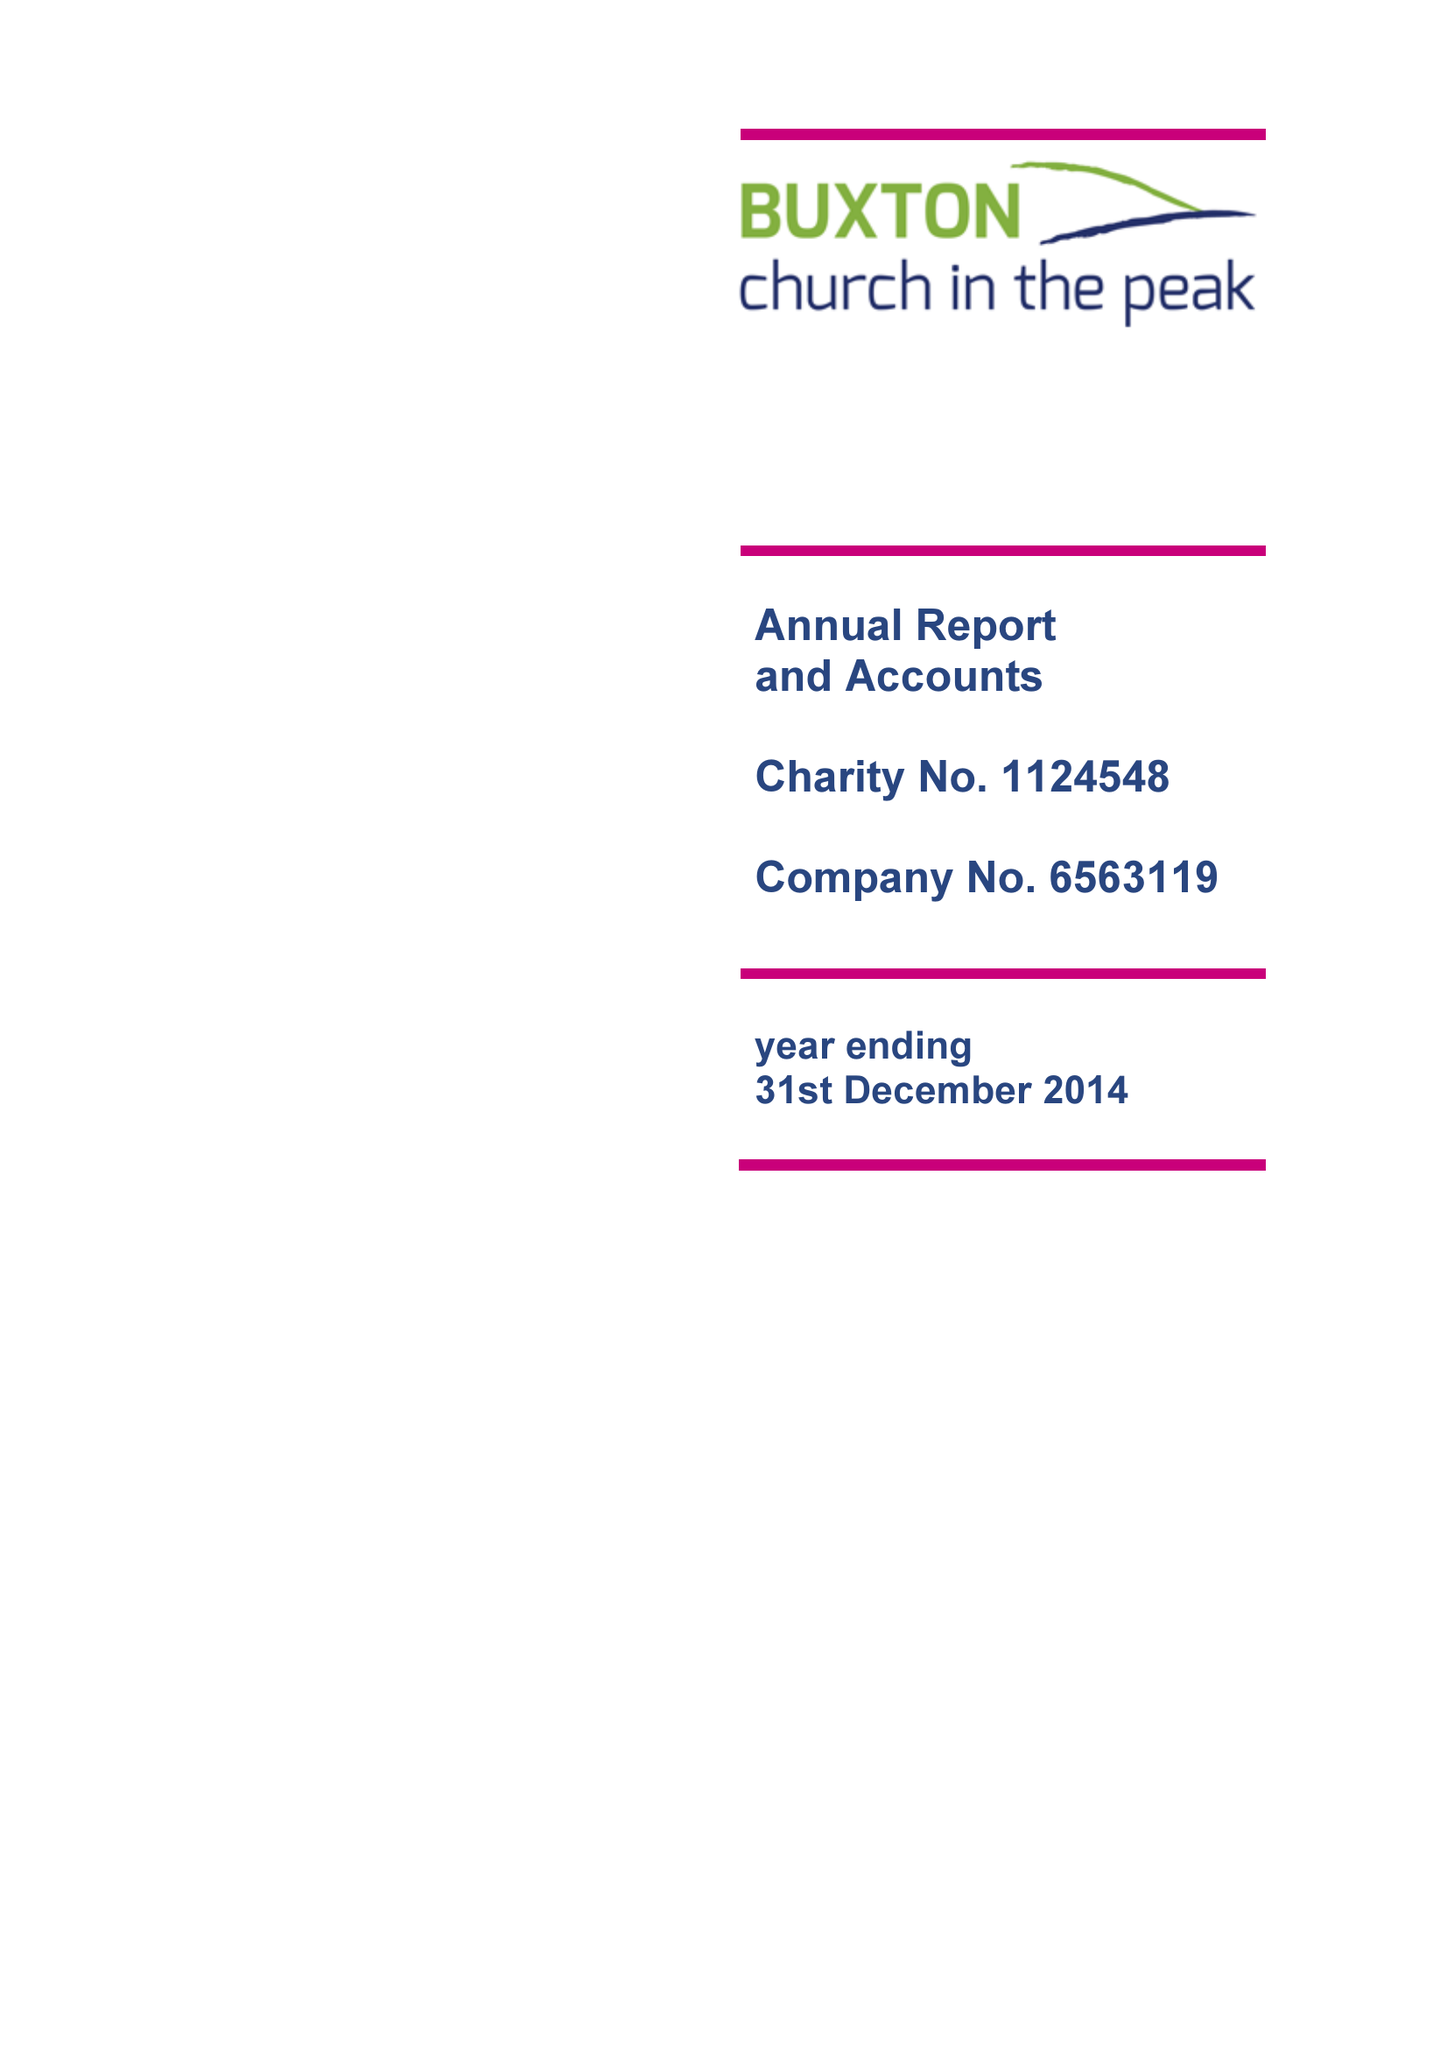What is the value for the address__postcode?
Answer the question using a single word or phrase. SK17 9AD 